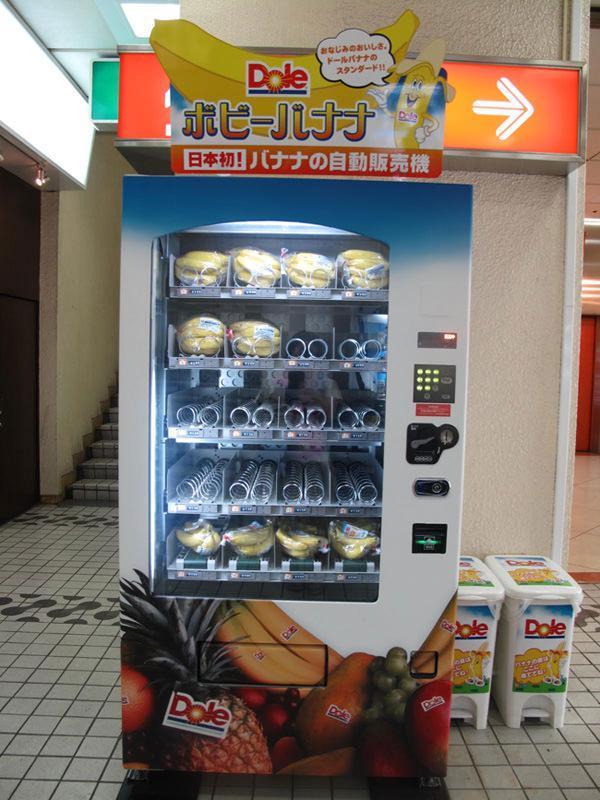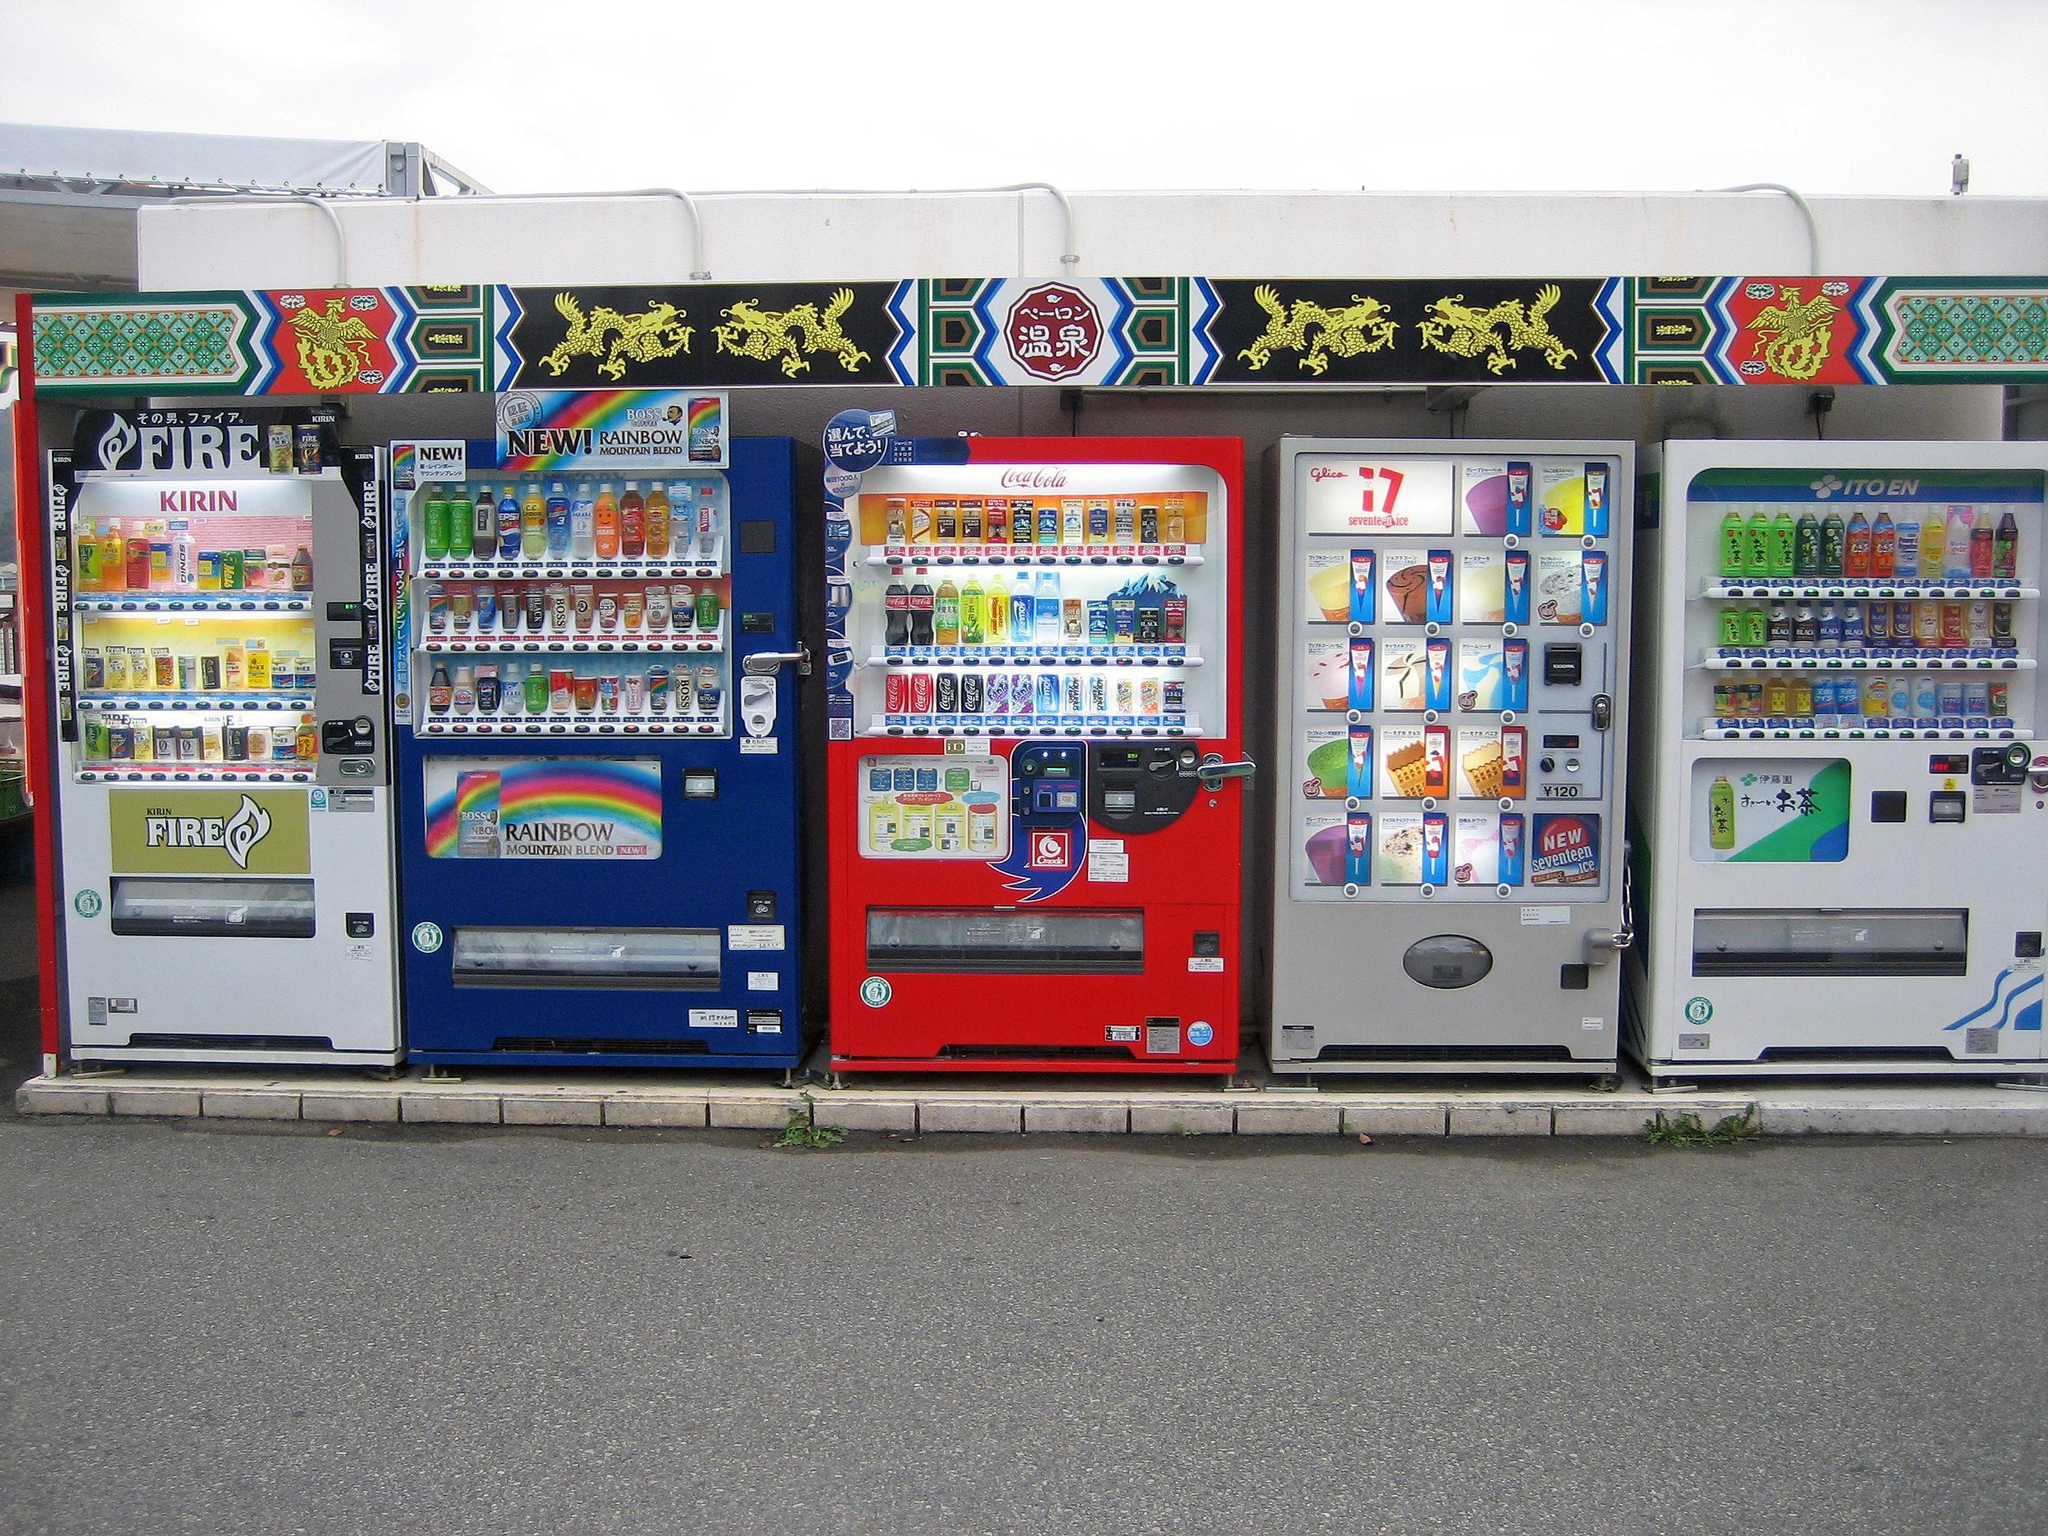The first image is the image on the left, the second image is the image on the right. For the images shown, is this caption "An image shows a row of exactly three vending machines." true? Answer yes or no. No. The first image is the image on the left, the second image is the image on the right. Considering the images on both sides, is "A bank of exactly three vending machines appears in one image." valid? Answer yes or no. No. 